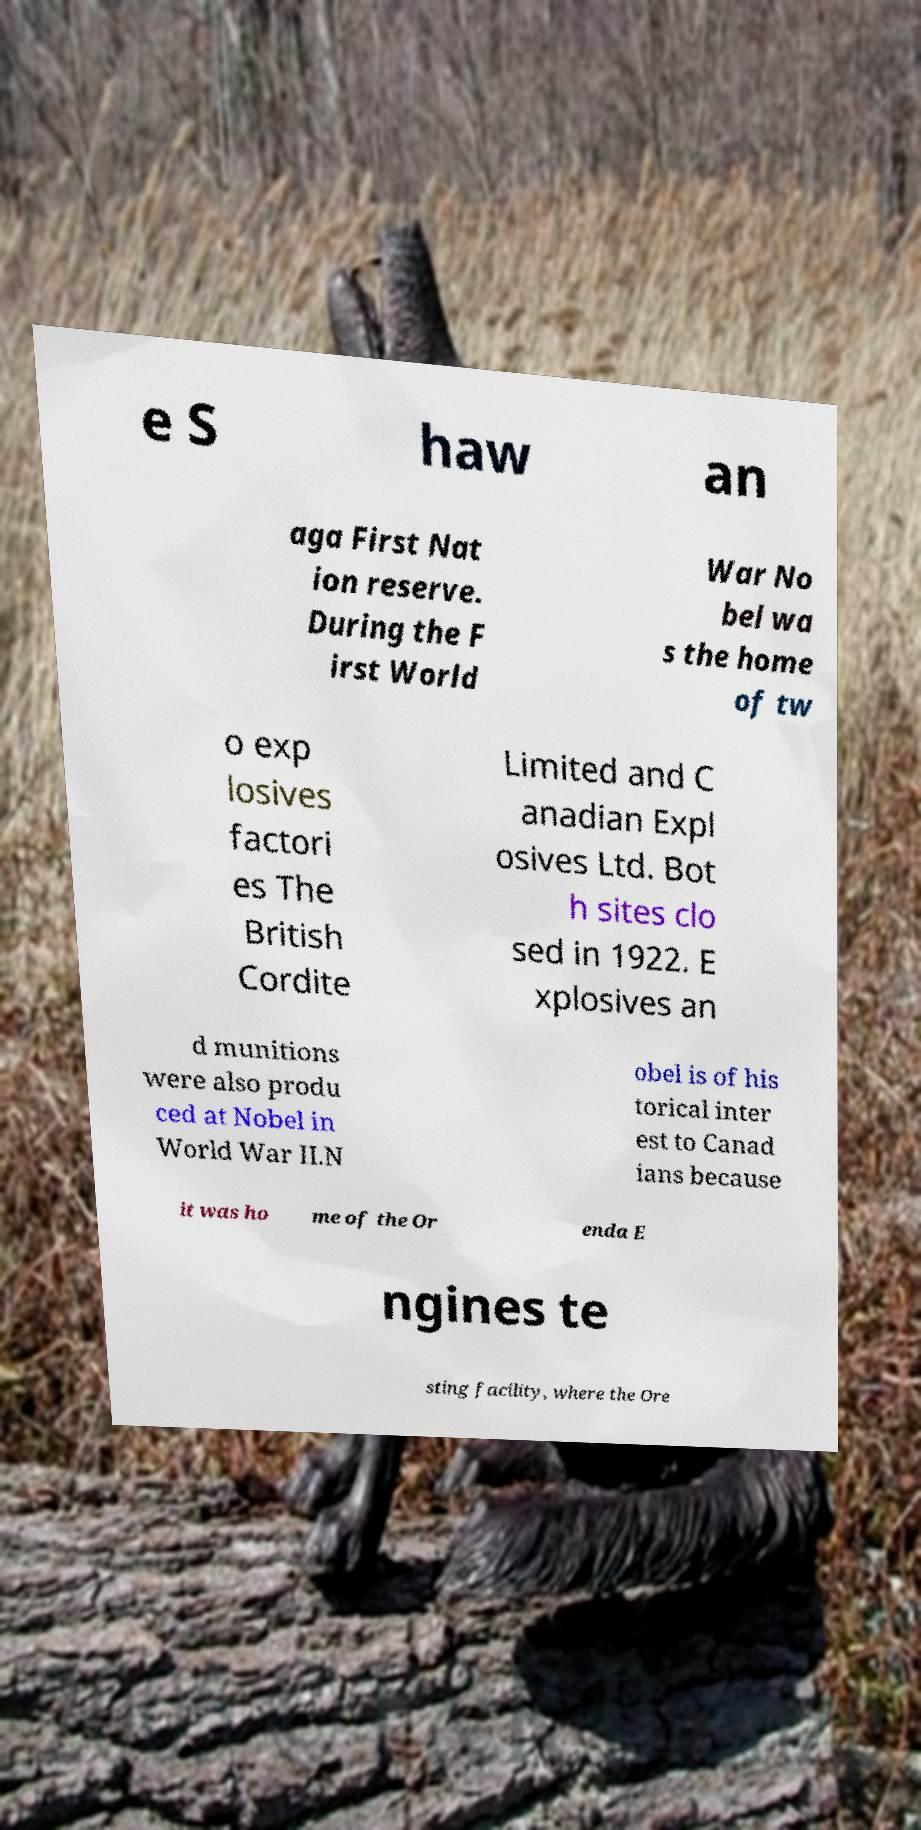Please read and relay the text visible in this image. What does it say? e S haw an aga First Nat ion reserve. During the F irst World War No bel wa s the home of tw o exp losives factori es The British Cordite Limited and C anadian Expl osives Ltd. Bot h sites clo sed in 1922. E xplosives an d munitions were also produ ced at Nobel in World War II.N obel is of his torical inter est to Canad ians because it was ho me of the Or enda E ngines te sting facility, where the Ore 